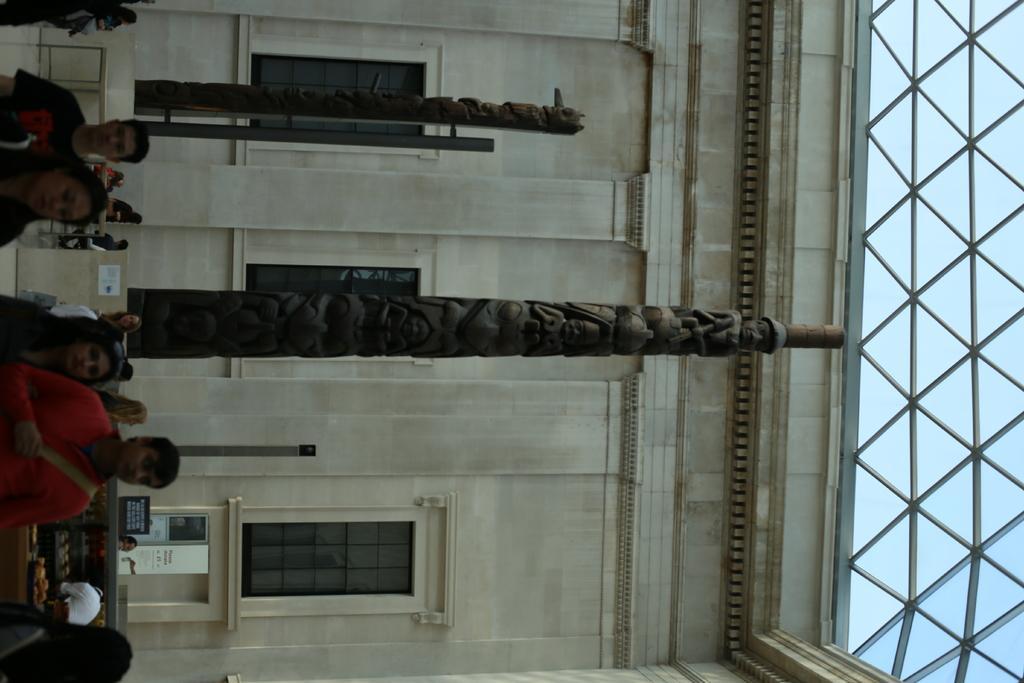Can you describe this image briefly? In this picture we can see some people on the left side, in the background there is a building, there are poles in the middle, on the right side there are some metal rods, we can see glass windows of this building, we can also see a board at the bottom. 